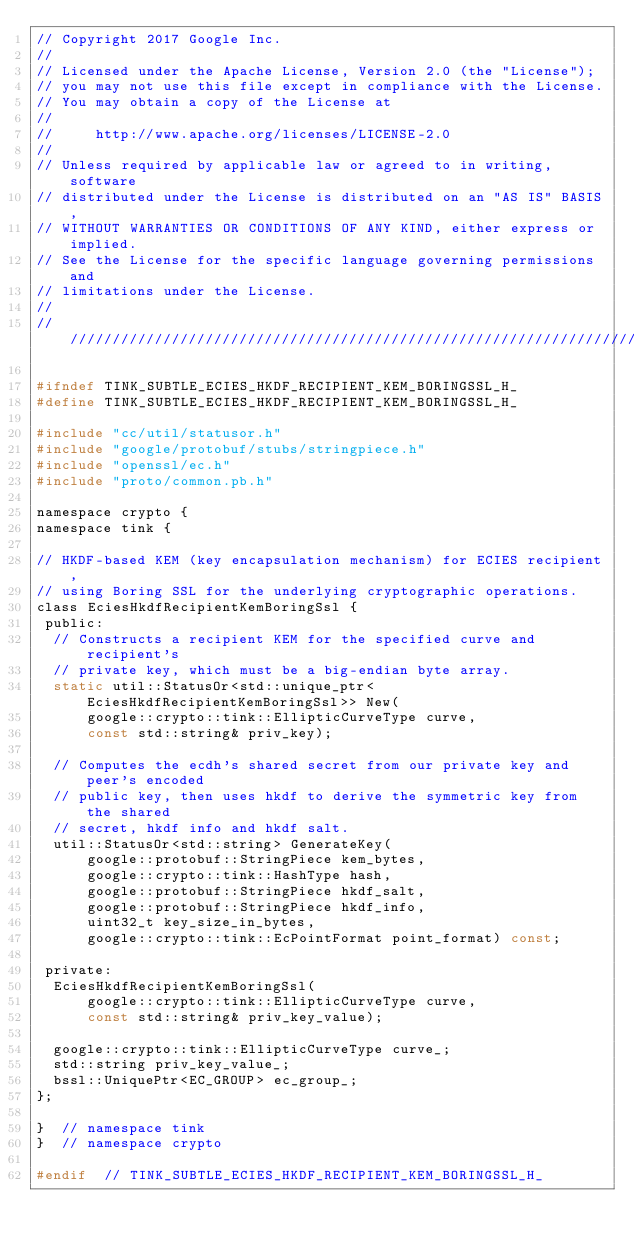Convert code to text. <code><loc_0><loc_0><loc_500><loc_500><_C_>// Copyright 2017 Google Inc.
//
// Licensed under the Apache License, Version 2.0 (the "License");
// you may not use this file except in compliance with the License.
// You may obtain a copy of the License at
//
//     http://www.apache.org/licenses/LICENSE-2.0
//
// Unless required by applicable law or agreed to in writing, software
// distributed under the License is distributed on an "AS IS" BASIS,
// WITHOUT WARRANTIES OR CONDITIONS OF ANY KIND, either express or implied.
// See the License for the specific language governing permissions and
// limitations under the License.
//
///////////////////////////////////////////////////////////////////////////////

#ifndef TINK_SUBTLE_ECIES_HKDF_RECIPIENT_KEM_BORINGSSL_H_
#define TINK_SUBTLE_ECIES_HKDF_RECIPIENT_KEM_BORINGSSL_H_

#include "cc/util/statusor.h"
#include "google/protobuf/stubs/stringpiece.h"
#include "openssl/ec.h"
#include "proto/common.pb.h"

namespace crypto {
namespace tink {

// HKDF-based KEM (key encapsulation mechanism) for ECIES recipient,
// using Boring SSL for the underlying cryptographic operations.
class EciesHkdfRecipientKemBoringSsl {
 public:
  // Constructs a recipient KEM for the specified curve and recipient's
  // private key, which must be a big-endian byte array.
  static util::StatusOr<std::unique_ptr<EciesHkdfRecipientKemBoringSsl>> New(
      google::crypto::tink::EllipticCurveType curve,
      const std::string& priv_key);

  // Computes the ecdh's shared secret from our private key and peer's encoded
  // public key, then uses hkdf to derive the symmetric key from the shared
  // secret, hkdf info and hkdf salt.
  util::StatusOr<std::string> GenerateKey(
      google::protobuf::StringPiece kem_bytes,
      google::crypto::tink::HashType hash,
      google::protobuf::StringPiece hkdf_salt,
      google::protobuf::StringPiece hkdf_info,
      uint32_t key_size_in_bytes,
      google::crypto::tink::EcPointFormat point_format) const;

 private:
  EciesHkdfRecipientKemBoringSsl(
      google::crypto::tink::EllipticCurveType curve,
      const std::string& priv_key_value);

  google::crypto::tink::EllipticCurveType curve_;
  std::string priv_key_value_;
  bssl::UniquePtr<EC_GROUP> ec_group_;
};

}  // namespace tink
}  // namespace crypto

#endif  // TINK_SUBTLE_ECIES_HKDF_RECIPIENT_KEM_BORINGSSL_H_
</code> 